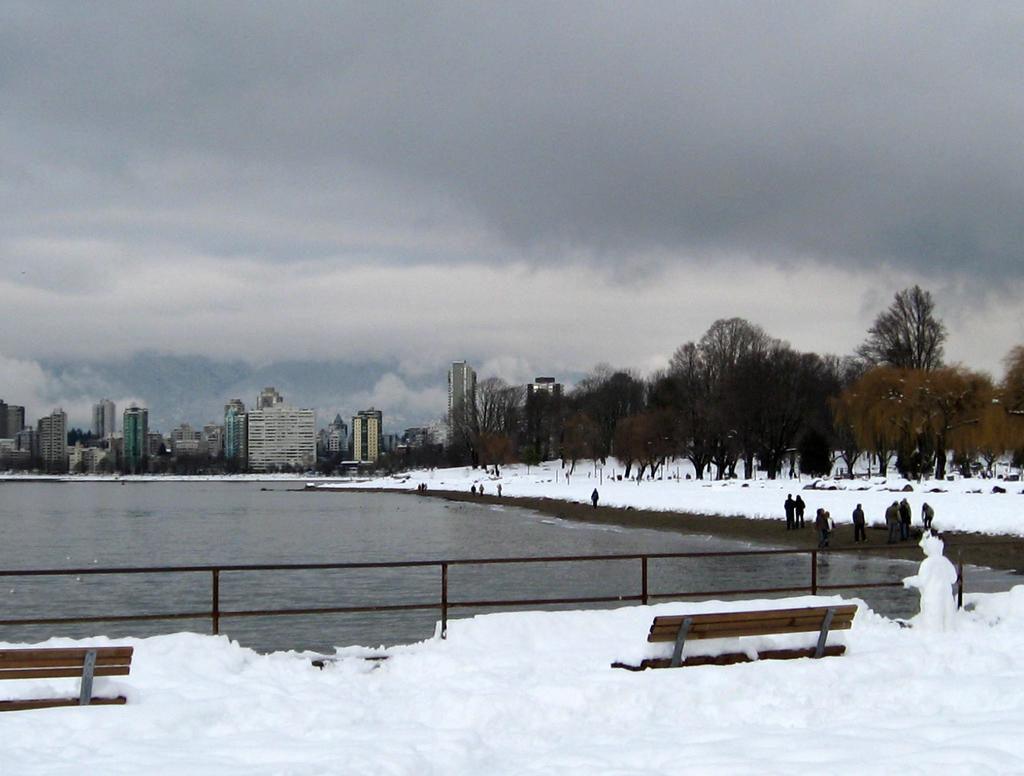What is the main feature in the center of the image? There is water in the center of the image. What can be seen at the bottom of the image? There is snow and benches at the bottom of the image. What is visible in the background of the image? There are trees, snow, buildings, the sky, and clouds in the background of the image. What type of mine can be seen in the image? There is no mine present in the image. How does the fear of heights affect the people in the image? There are no people present in the image, so it is impossible to determine how fear of heights might affect them. 